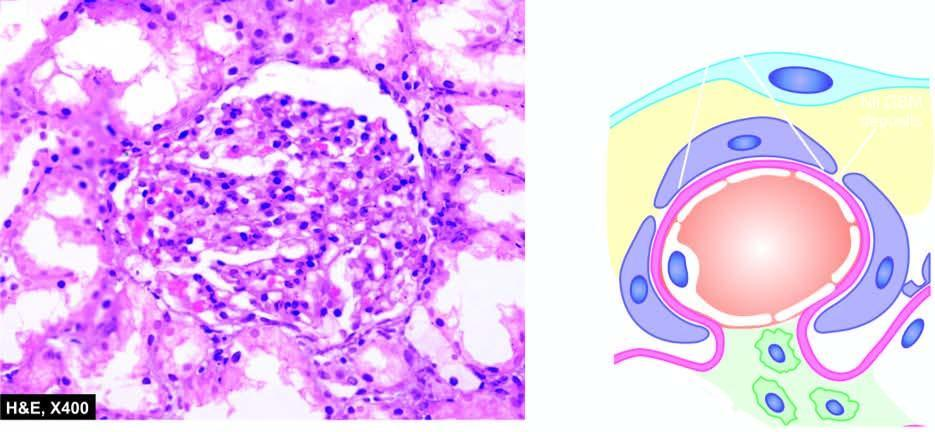do tubules show cytoplasmic?
Answer the question using a single word or phrase. Yes 